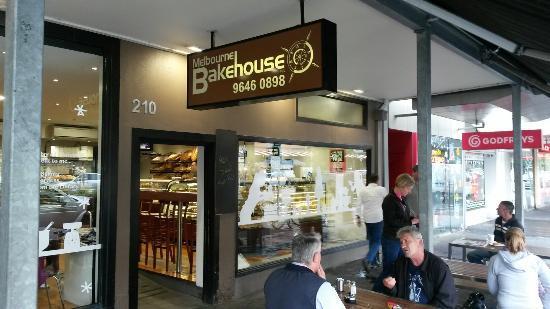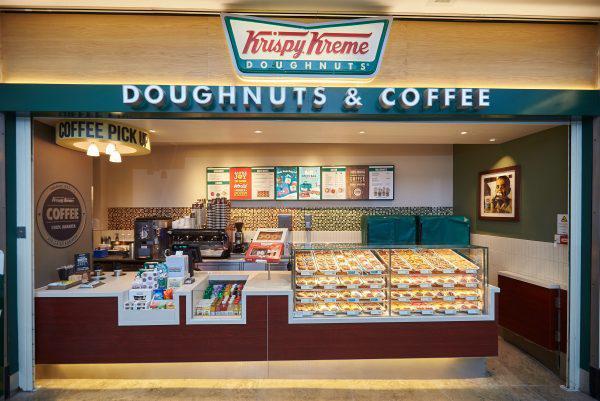The first image is the image on the left, the second image is the image on the right. Assess this claim about the two images: "Both images show bakeries with the same name.". Correct or not? Answer yes or no. No. The first image is the image on the left, the second image is the image on the right. For the images shown, is this caption "People are standing in front of a restaurant." true? Answer yes or no. Yes. 